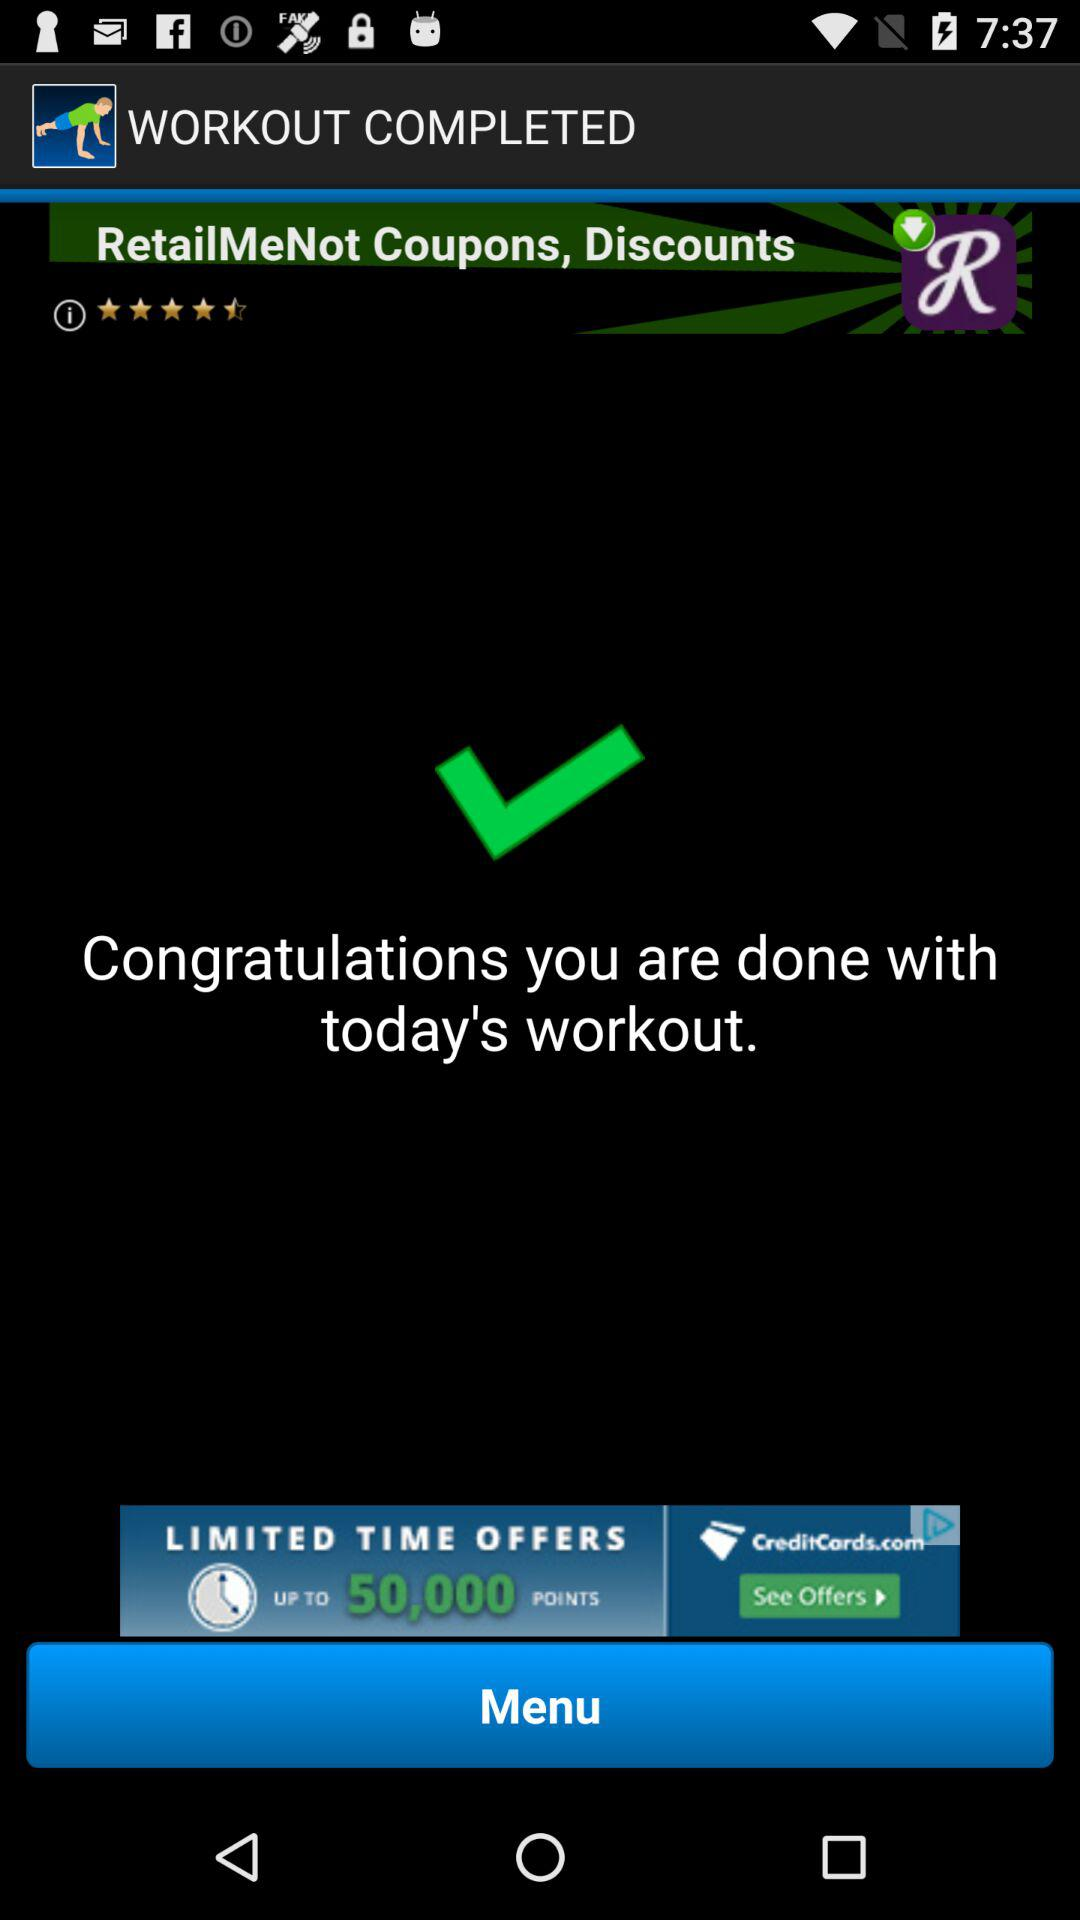Is today's workout over? Today's workout is over. 